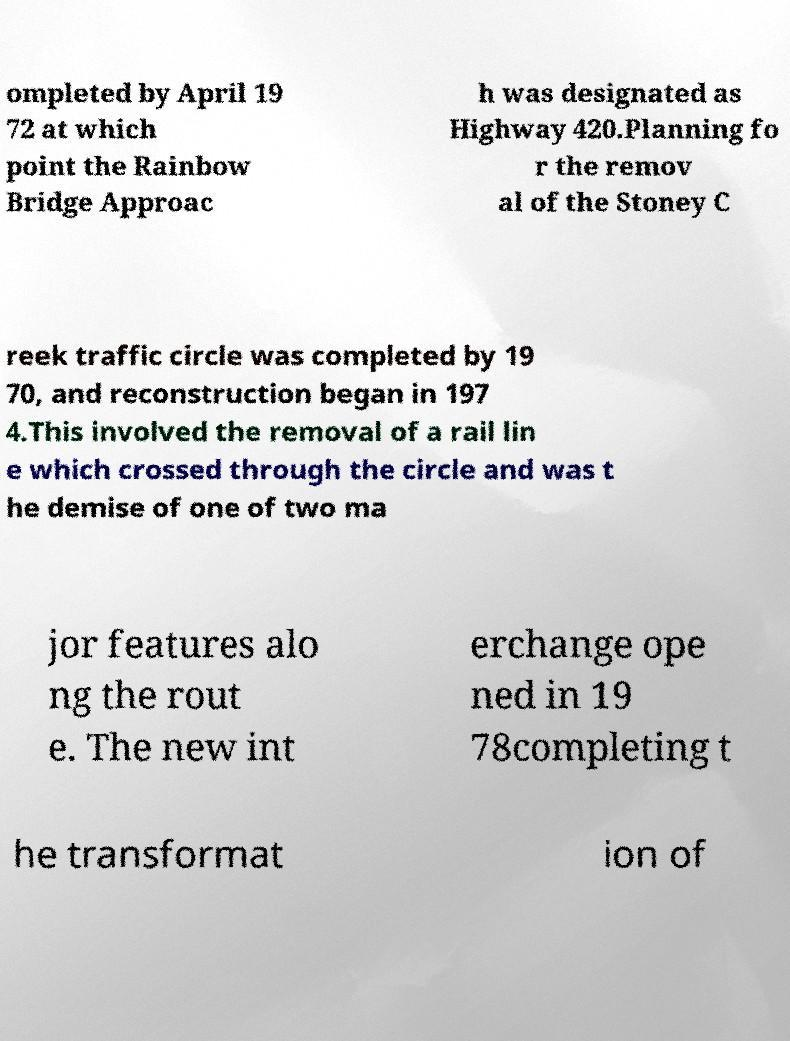Please identify and transcribe the text found in this image. ompleted by April 19 72 at which point the Rainbow Bridge Approac h was designated as Highway 420.Planning fo r the remov al of the Stoney C reek traffic circle was completed by 19 70, and reconstruction began in 197 4.This involved the removal of a rail lin e which crossed through the circle and was t he demise of one of two ma jor features alo ng the rout e. The new int erchange ope ned in 19 78completing t he transformat ion of 